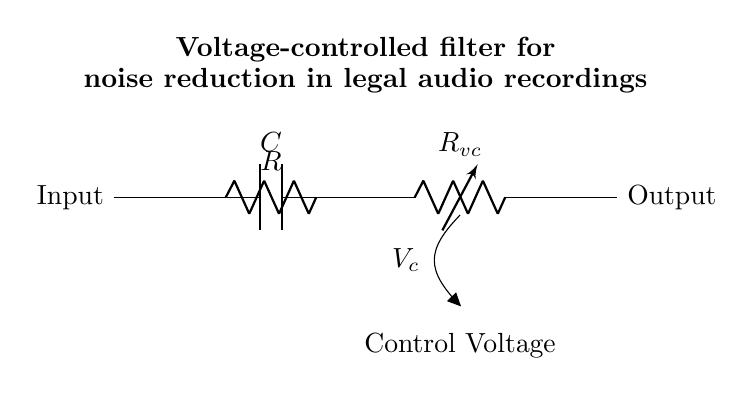What type of capacitor is used in this circuit? The circuit diagram shows a standard capacitor typically used for filtering; it is labeled as C.
Answer: Capacitor What is the purpose of the voltage-controlled resistor? The voltage-controlled resistor, labeled Rvc, adjusts its resistance based on the control voltage, allowing for dynamic filtering of signals in the circuit.
Answer: Dynamic filtering How many main components are there in the circuit? The circuit consists of three main components: a resistor, a capacitor, and a voltage-controlled resistor.
Answer: Three What is the input of the circuit labeled as? The input is labeled explicitly in the diagram as "Input," which indicates where the signal enters the circuit.
Answer: Input How does the control voltage affect the circuit operation? The control voltage affects the resistance of the voltage-controlled resistor Rvc, which in turn influences the cutoff frequency of the RC filter, thus altering how much noise is reduced from the audio signal.
Answer: Alters resistance What effect does increasing the capacitance have on the filter? Increasing the capacitance in the circuit lowers the cutoff frequency, allowing more low-frequency signals to pass through and potentially filtering out more noise.
Answer: Lowers cutoff frequency What is the output of the circuit labeled as? The output is labeled explicitly in the circuit diagram as "Output," indicating where the filtered signal is taken from the circuit.
Answer: Output 